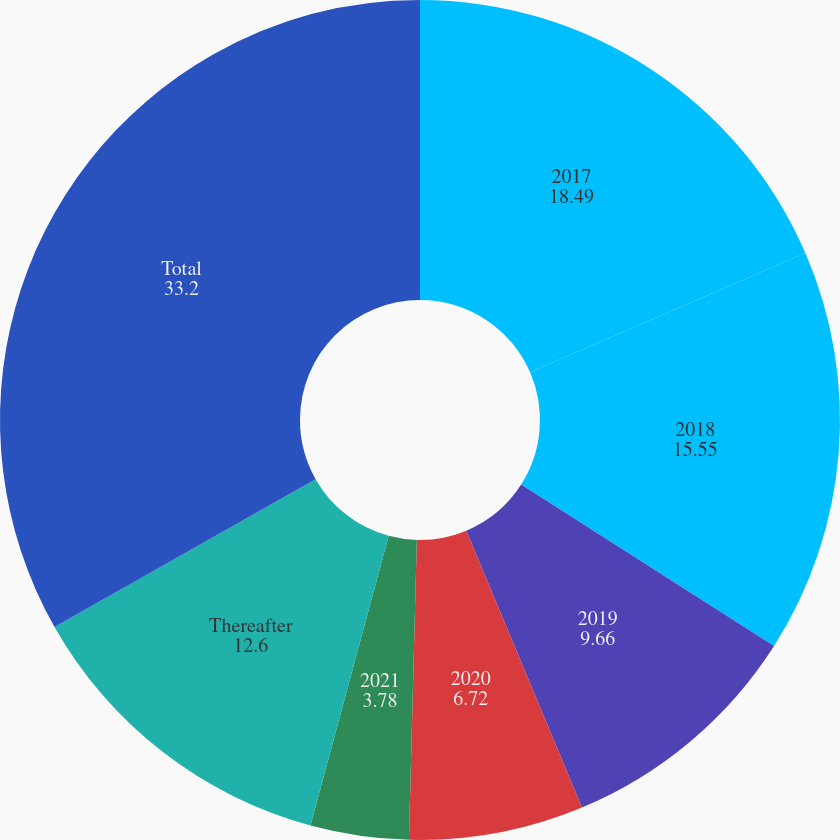<chart> <loc_0><loc_0><loc_500><loc_500><pie_chart><fcel>2017<fcel>2018<fcel>2019<fcel>2020<fcel>2021<fcel>Thereafter<fcel>Total<nl><fcel>18.49%<fcel>15.55%<fcel>9.66%<fcel>6.72%<fcel>3.78%<fcel>12.6%<fcel>33.2%<nl></chart> 